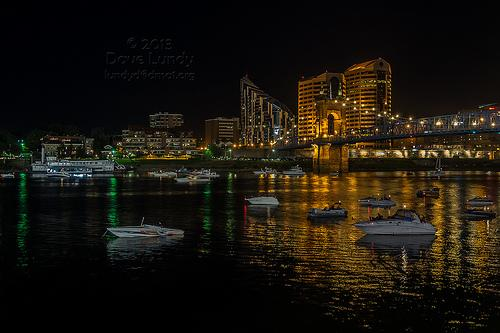In the given image, identify any reflections or color interplay in the water. There are reflections in the water, including light and colors from the city, bridge, and boats. Yellow, green, and red lights are also featured in the reflections. Count the number of boats in the water and describe their color. There are 10 boats in the water, one of them being white with a red light shining on the water, and the others' colors are not specified. Based on the information given, evaluate the quality of the image. The image is detailed and comprehensive, capturing various objects such as the city, bridge, boats, and lighting reflections, showcasing different elements and interactions between them. How many objects in the image are related to lighting and reflections? There are 7 objects related to lighting and reflections, including various lights on buildings, the bridge, and boats, as well as reflections in the water. What is the central focus or interaction happening in the image? The primary focus is on the boats in the water, with interactions like reflections of light and colors on the water's surface. Can you provide a brief summary of the most prominent features of the image? The image features a city with many buildings in the background, a bridge, multiple boats in the water, and reflections of light on the water surface. Please provide a poetic description of the image. In the calm embrace of the water, boats rest gently, their journeys paused. The city stands proud in the distance, its lights dancing on the surface, a bridge connecting worlds above and below. What kind of sentiment or emotion can be associated with this image? The image conveys a serene and peaceful atmosphere, with the boats floating calmly in the water against the backdrop of the city and bridge. Notice the hot air balloon floating in the sky above the boats. It's quite colorful and distracting. There's no information given about a hot air balloon in the provided data. This instruction is misleading because it describes an object that doesn't exist, asking the user to focus on something that isn't present in the image. Do you see the dolphin jumping out of the water near the boats? It must be attracted by the city lights.” No, it's not mentioned in the image. Could you point out the person swimming in the water near the bridge? They must be very brave to swim in such a busy area. No information is given about a person swimming in the water. This instruction is misleading as it creates a false narrative about a person swimming in the busy water, which doesn't exist in the image. 